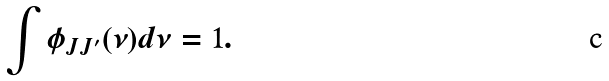Convert formula to latex. <formula><loc_0><loc_0><loc_500><loc_500>\int \phi _ { J J ^ { \prime } } ( \nu ) d \nu = 1 .</formula> 